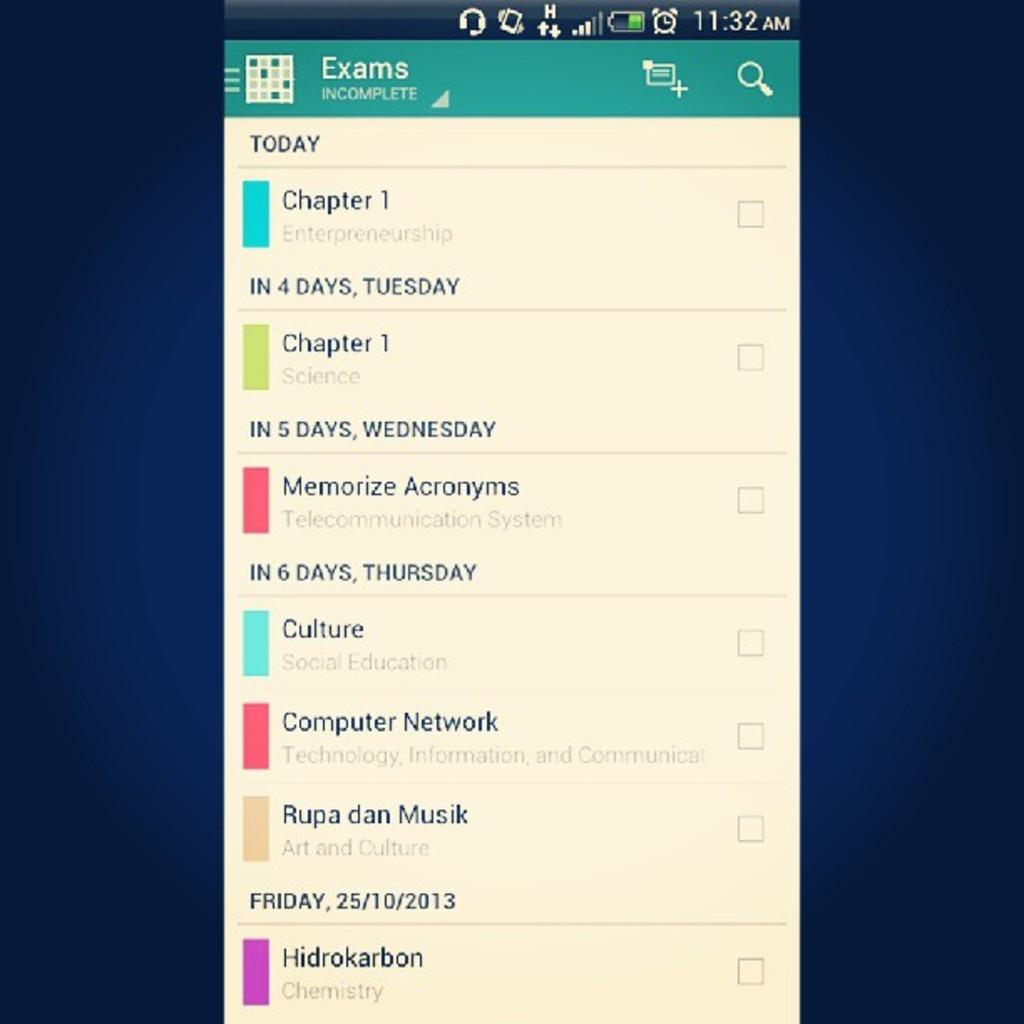<image>
Offer a succinct explanation of the picture presented. A calendar app that shows what exams are coming up. 